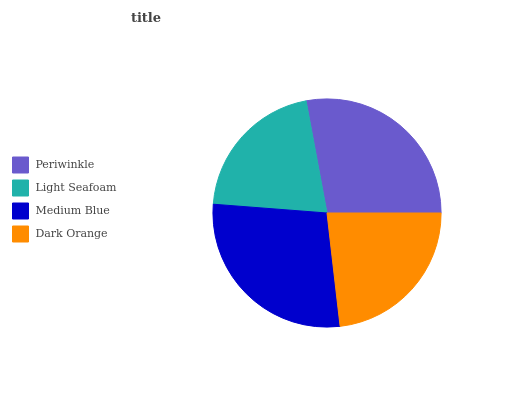Is Light Seafoam the minimum?
Answer yes or no. Yes. Is Medium Blue the maximum?
Answer yes or no. Yes. Is Medium Blue the minimum?
Answer yes or no. No. Is Light Seafoam the maximum?
Answer yes or no. No. Is Medium Blue greater than Light Seafoam?
Answer yes or no. Yes. Is Light Seafoam less than Medium Blue?
Answer yes or no. Yes. Is Light Seafoam greater than Medium Blue?
Answer yes or no. No. Is Medium Blue less than Light Seafoam?
Answer yes or no. No. Is Periwinkle the high median?
Answer yes or no. Yes. Is Dark Orange the low median?
Answer yes or no. Yes. Is Light Seafoam the high median?
Answer yes or no. No. Is Medium Blue the low median?
Answer yes or no. No. 